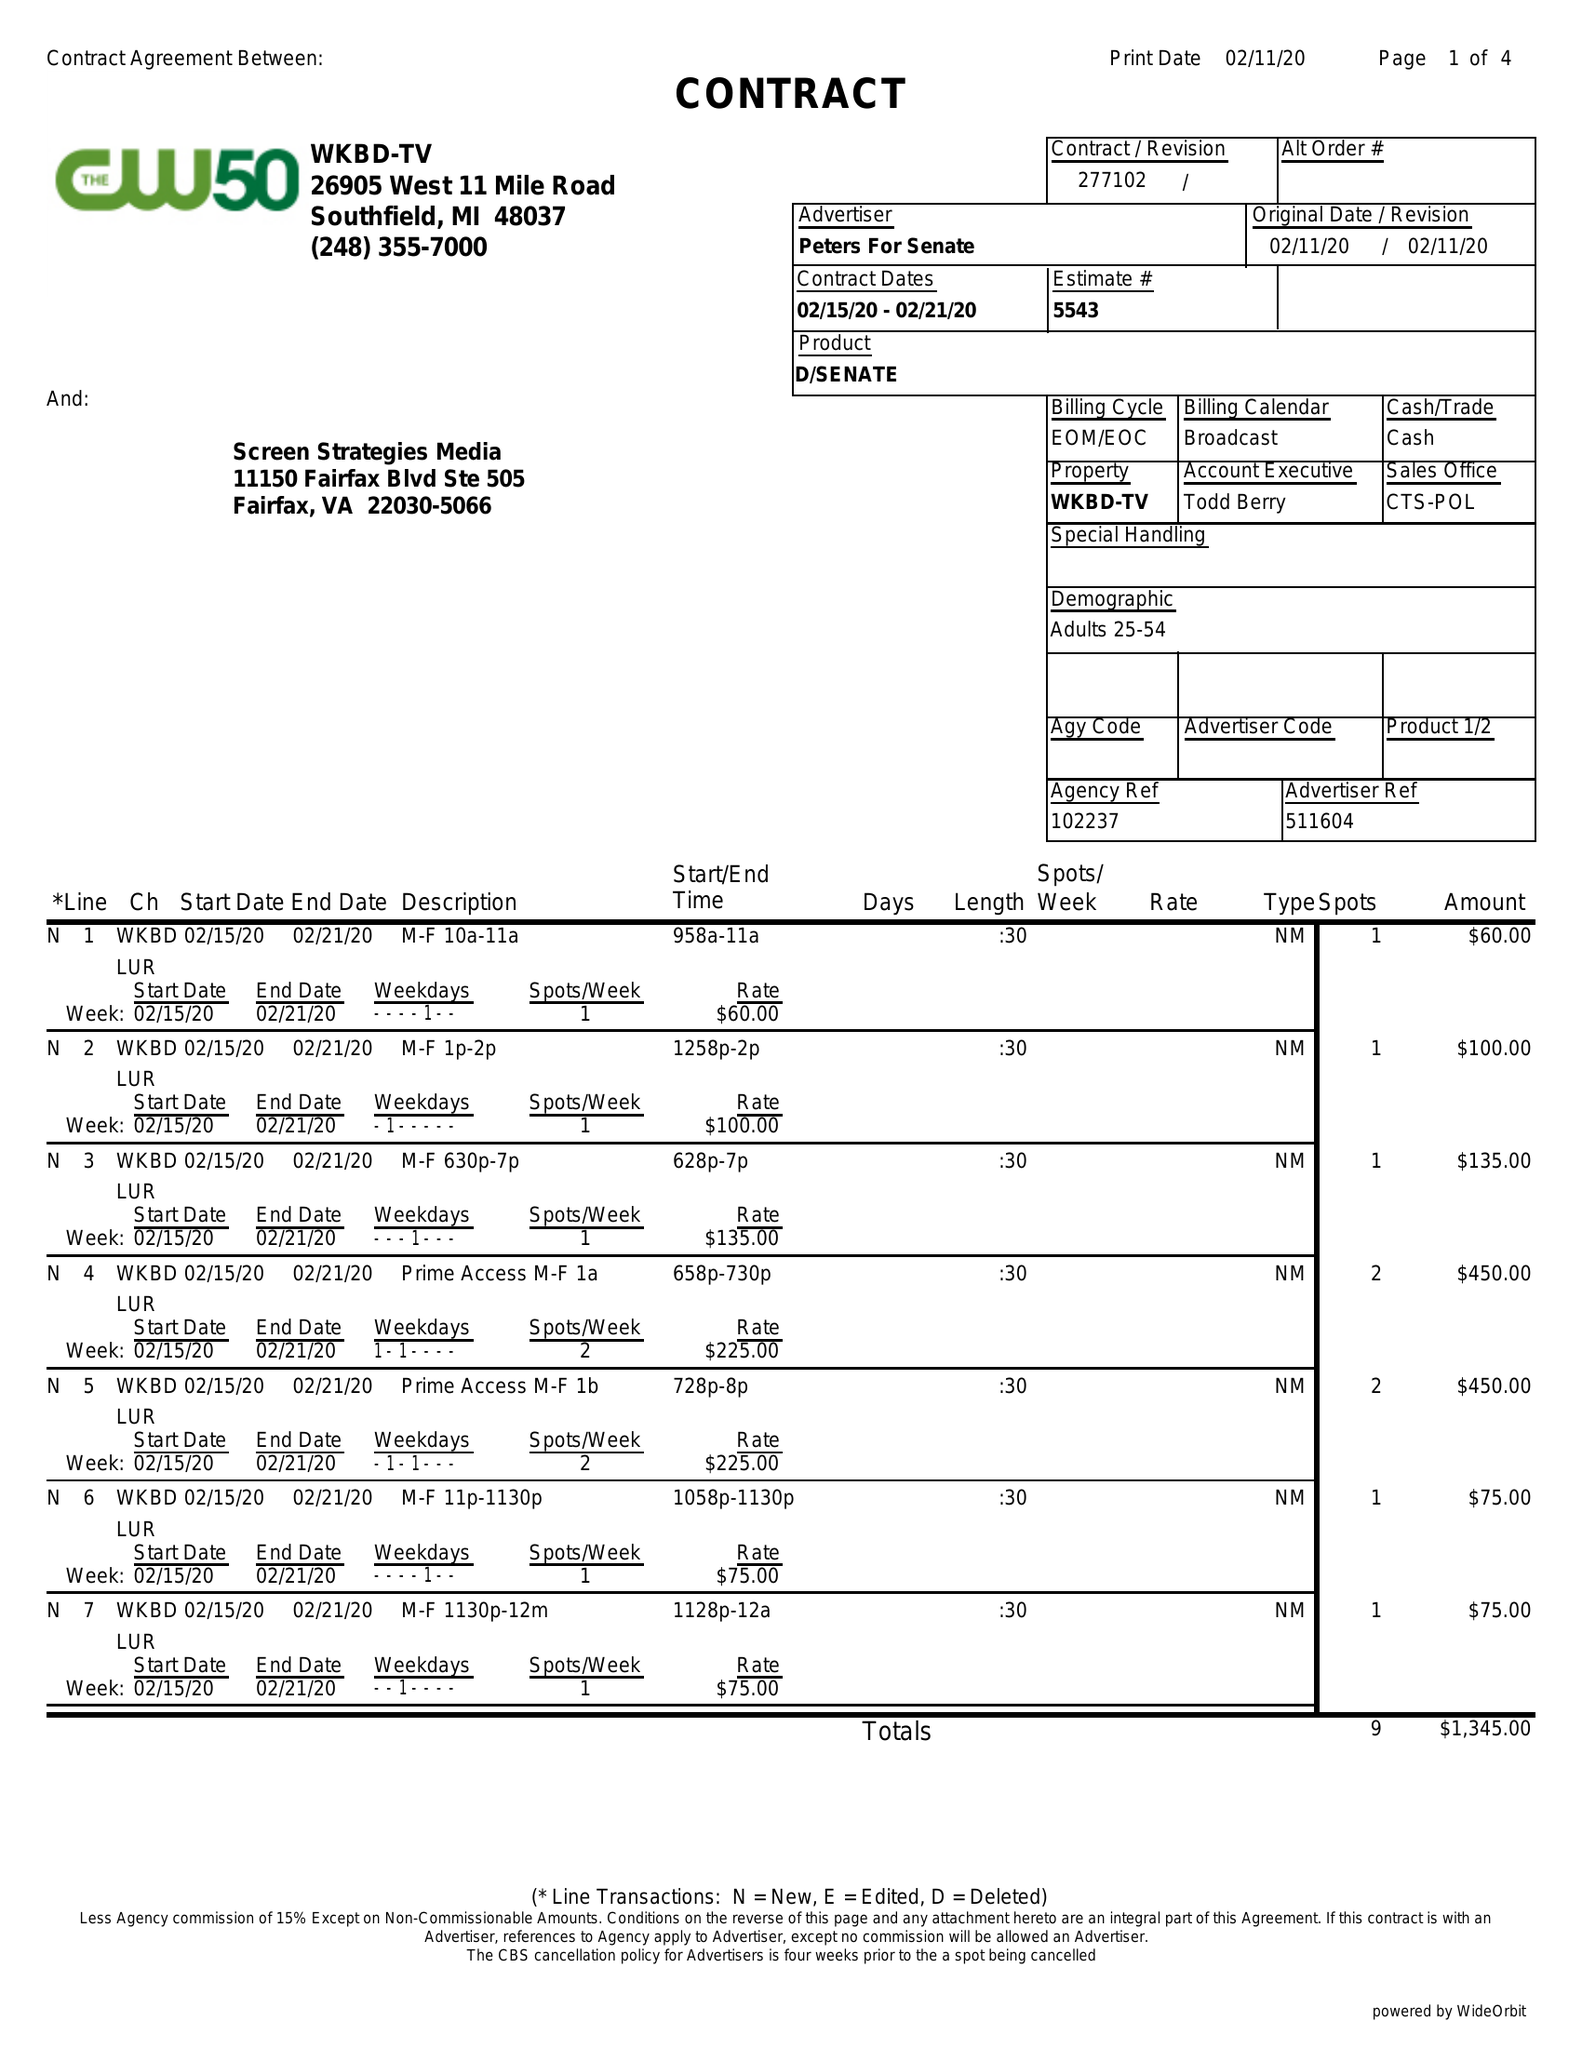What is the value for the flight_from?
Answer the question using a single word or phrase. 02/15/20 